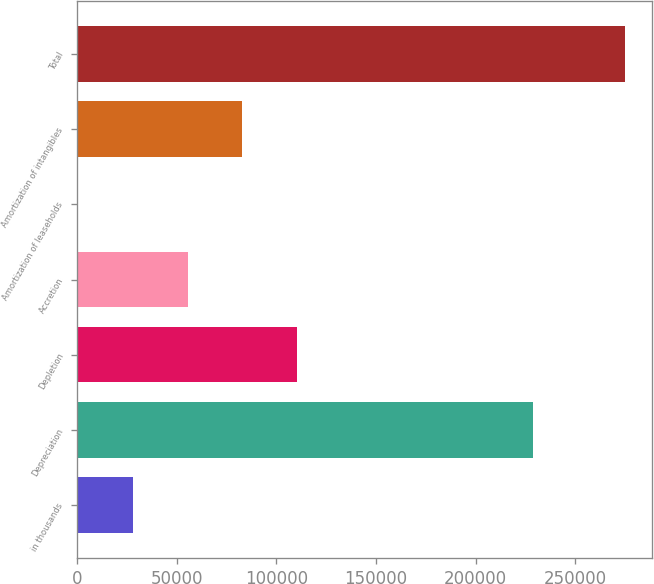Convert chart. <chart><loc_0><loc_0><loc_500><loc_500><bar_chart><fcel>in thousands<fcel>Depreciation<fcel>Depletion<fcel>Accretion<fcel>Amortization of leaseholds<fcel>Amortization of intangibles<fcel>Total<nl><fcel>28101.5<fcel>228866<fcel>110342<fcel>55515<fcel>688<fcel>82928.5<fcel>274823<nl></chart> 